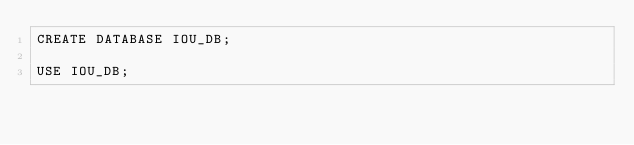<code> <loc_0><loc_0><loc_500><loc_500><_SQL_>CREATE DATABASE IOU_DB;

USE IOU_DB;
</code> 